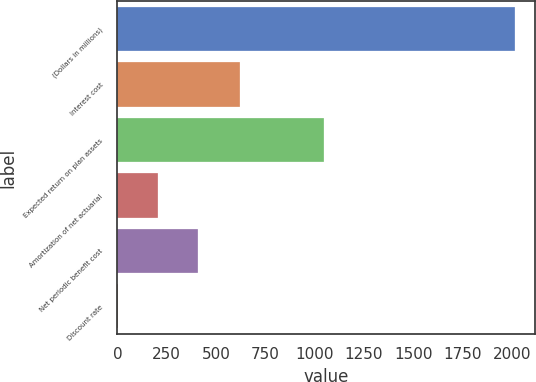Convert chart. <chart><loc_0><loc_0><loc_500><loc_500><bar_chart><fcel>(Dollars in millions)<fcel>Interest cost<fcel>Expected return on plan assets<fcel>Amortization of net actuarial<fcel>Net periodic benefit cost<fcel>Discount rate<nl><fcel>2015<fcel>621<fcel>1045<fcel>205.21<fcel>406.3<fcel>4.12<nl></chart> 